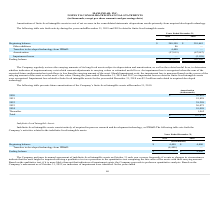According to Maxlinear's financial document, When is the impairment loss recognized? when the sum of the expected future undiscounted net cash flows is less than the carrying amount of the asset.. The document states: "ted useful lives. An impairment loss is recognized when the sum of the expected future undiscounted net cash flows is less than the carrying amount of..." Also, What was the Impairment loss related to finite-lived intangible assets in 2018? According to the financial document, $2.2 million. The relevant text states: "le assets for the year ended December 31, 2018 was $2.2 million and related to acquired developed technology...." Also, What were the other additions in 2019 and 2018 respectively? The document shows two values: 86 and 0 (in thousands). From the document: "Other additions 86 — rth activity during the years ended December 31, 2019 and 2018 related to finite-lived intangible assets:..." Also, can you calculate: What was the change in the Beginning balance from 2018 to 2019? Based on the calculation: 240,500 - 310,645, the result is -70145 (in thousands). This is based on the information: "Beginning balance $ 240,500 $ 310,645 Beginning balance $ 240,500 $ 310,645..." The key data points involved are: 240,500, 310,645. Also, can you calculate: What is the average other additions for 2018 and 2019? To answer this question, I need to perform calculations using the financial data. The calculation is: (86 + 0) / 2, which equals 43 (in thousands). This is based on the information: "Other additions 86 — rth activity during the years ended December 31, 2019 and 2018 related to finite-lived intangible assets:..." The key data points involved are: 0, 86. Additionally, In which year was Transfers to developed technology from IPR&D greater than 4,000 thousands? According to the financial document, 2019. The relevant text states: "orth activity during the years ended December 31, 2019 and 2018 related to finite-lived intangible assets:..." 